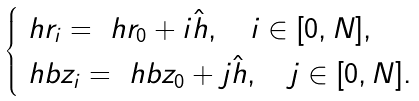Convert formula to latex. <formula><loc_0><loc_0><loc_500><loc_500>\begin{cases} \ h r _ { i } = \ h r _ { 0 } + i \hat { h } , \quad i \in [ 0 , N ] , \\ \ h b z _ { i } = \ h b z _ { 0 } + j \hat { h } , \quad j \in [ 0 , N ] . \end{cases}</formula> 